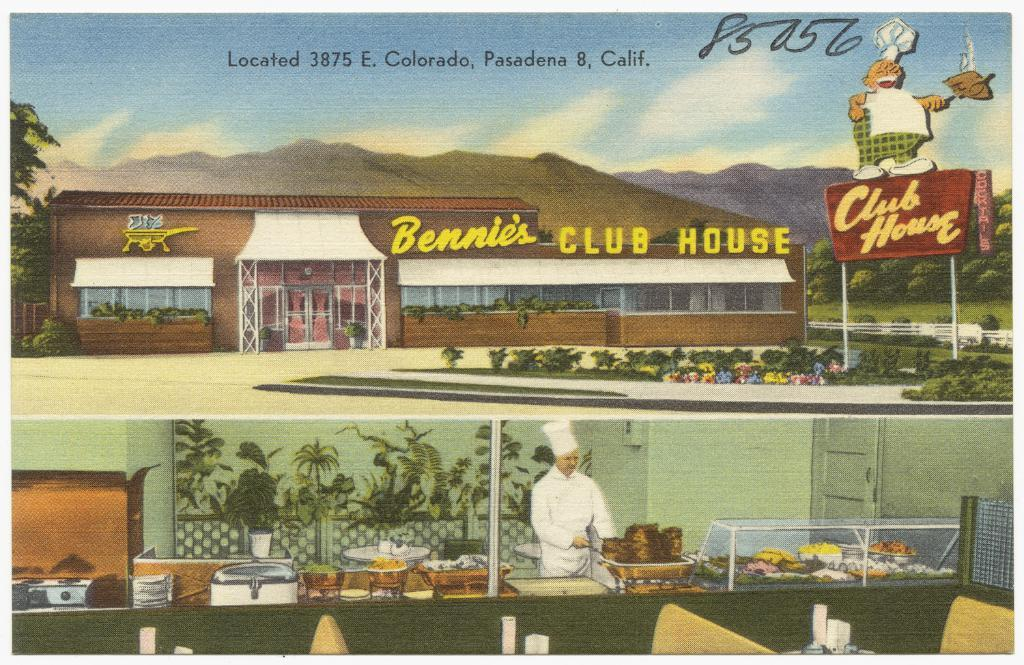What type of visual is the image? The image is a poster. What is depicted on the poster? There is a building depicted on the poster. What other objects can be seen in the image? There is a board, plants, trees, bowls, and a man preparing food in the image. What is the setting of the image? There is a wall, a door, and the sky is visible in the image. What is the weather like in the image? There are clouds in the sky, suggesting a partly cloudy day. How does the man say good-bye to the crook in the image? There is no crook present in the image, and the man is not interacting with anyone in the image. What type of current is flowing through the building in the image? There is no indication of any electrical current or power source in the image, and the building is depicted as a static image on the poster. 